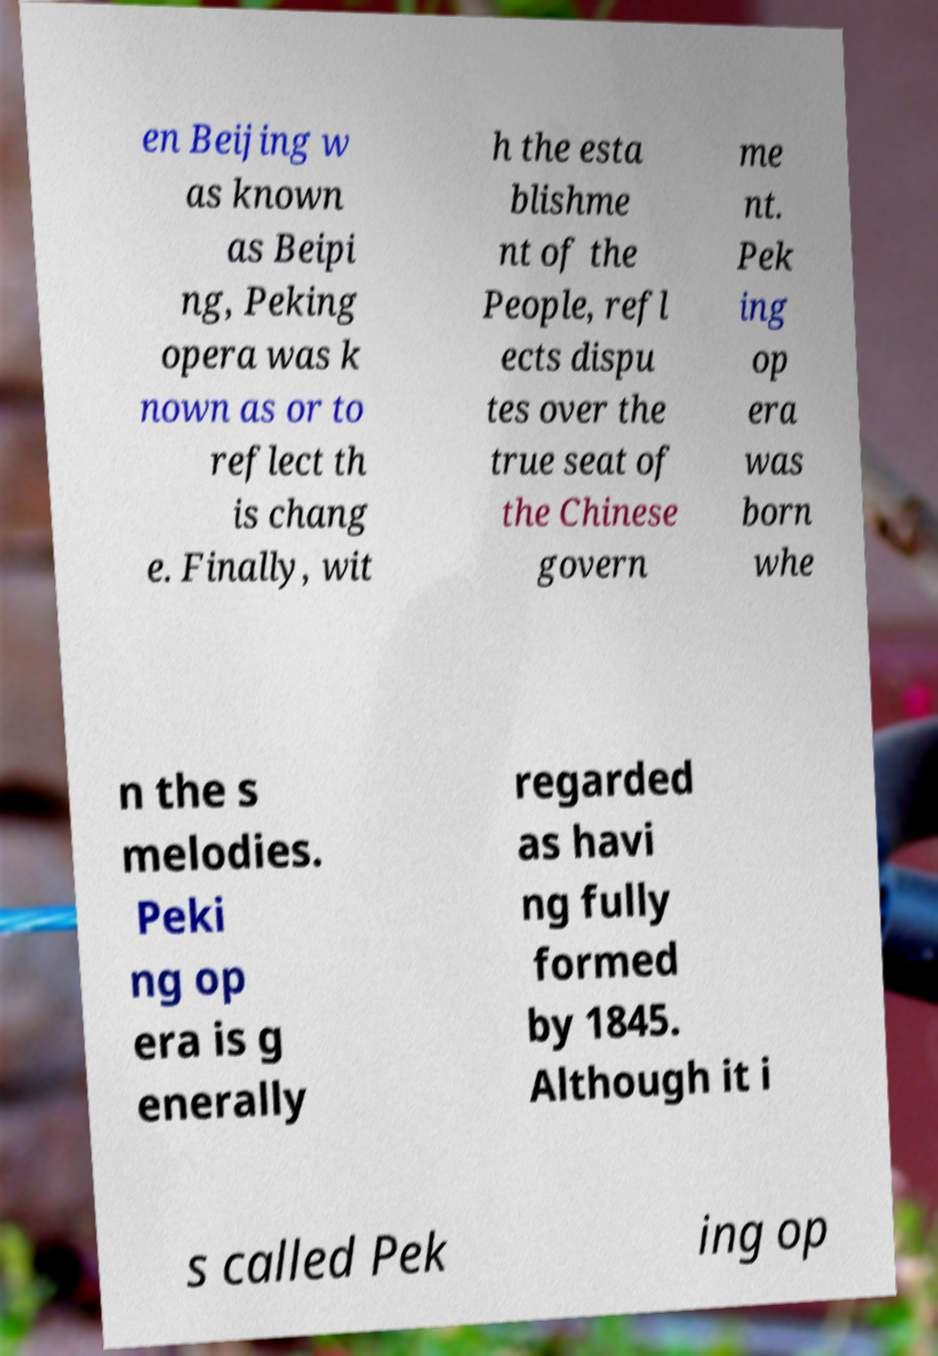Could you assist in decoding the text presented in this image and type it out clearly? en Beijing w as known as Beipi ng, Peking opera was k nown as or to reflect th is chang e. Finally, wit h the esta blishme nt of the People, refl ects dispu tes over the true seat of the Chinese govern me nt. Pek ing op era was born whe n the s melodies. Peki ng op era is g enerally regarded as havi ng fully formed by 1845. Although it i s called Pek ing op 